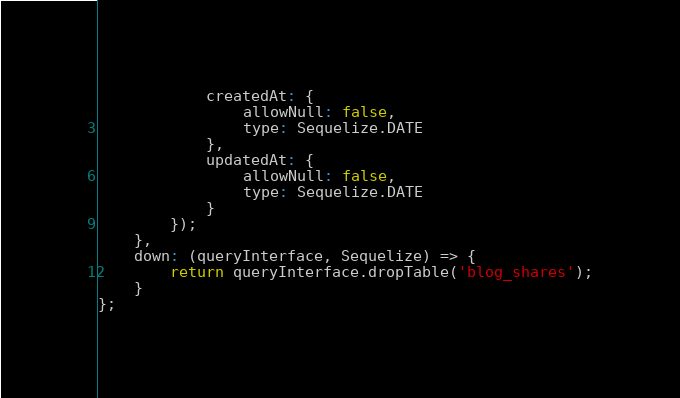<code> <loc_0><loc_0><loc_500><loc_500><_JavaScript_>			createdAt: {
				allowNull: false,
				type: Sequelize.DATE
			},
			updatedAt: {
				allowNull: false,
				type: Sequelize.DATE
			}
		});
	},
	down: (queryInterface, Sequelize) => {
		return queryInterface.dropTable('blog_shares');
	}
};
</code> 